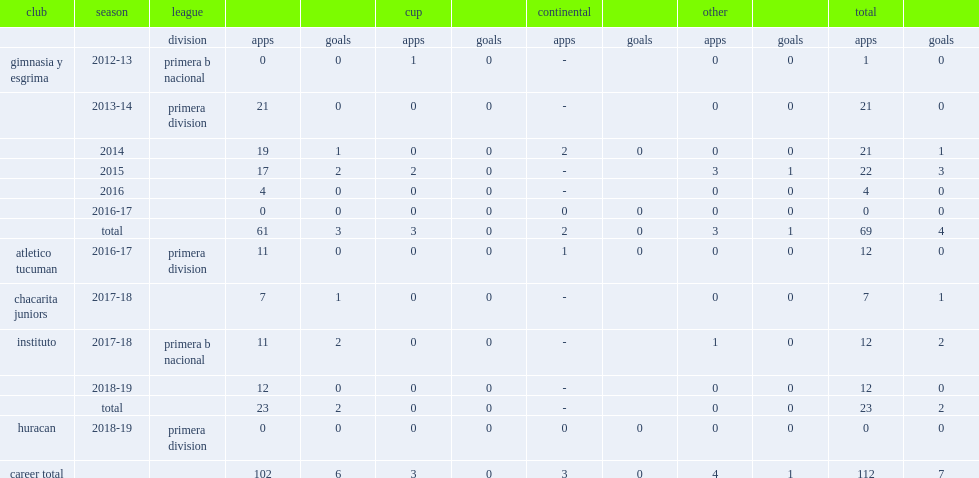Which club did mendoza play for in 2012-13? Gimnasia y esgrima. 